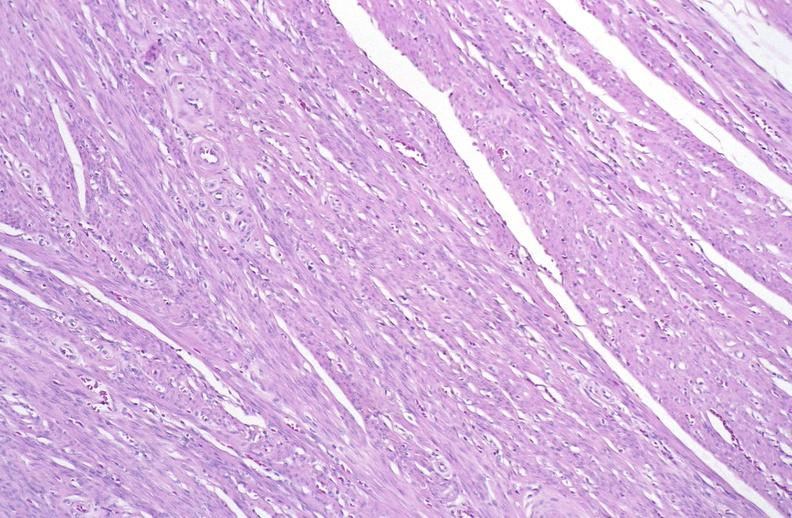what is present?
Answer the question using a single word or phrase. Female reproductive 